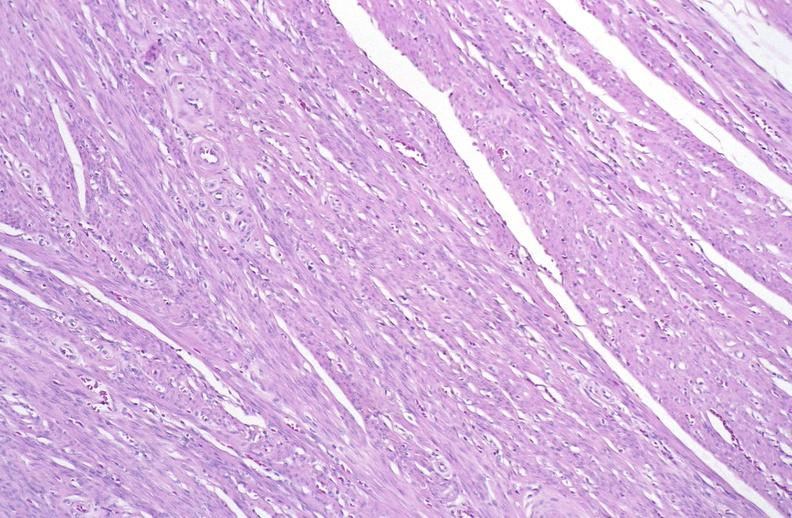what is present?
Answer the question using a single word or phrase. Female reproductive 